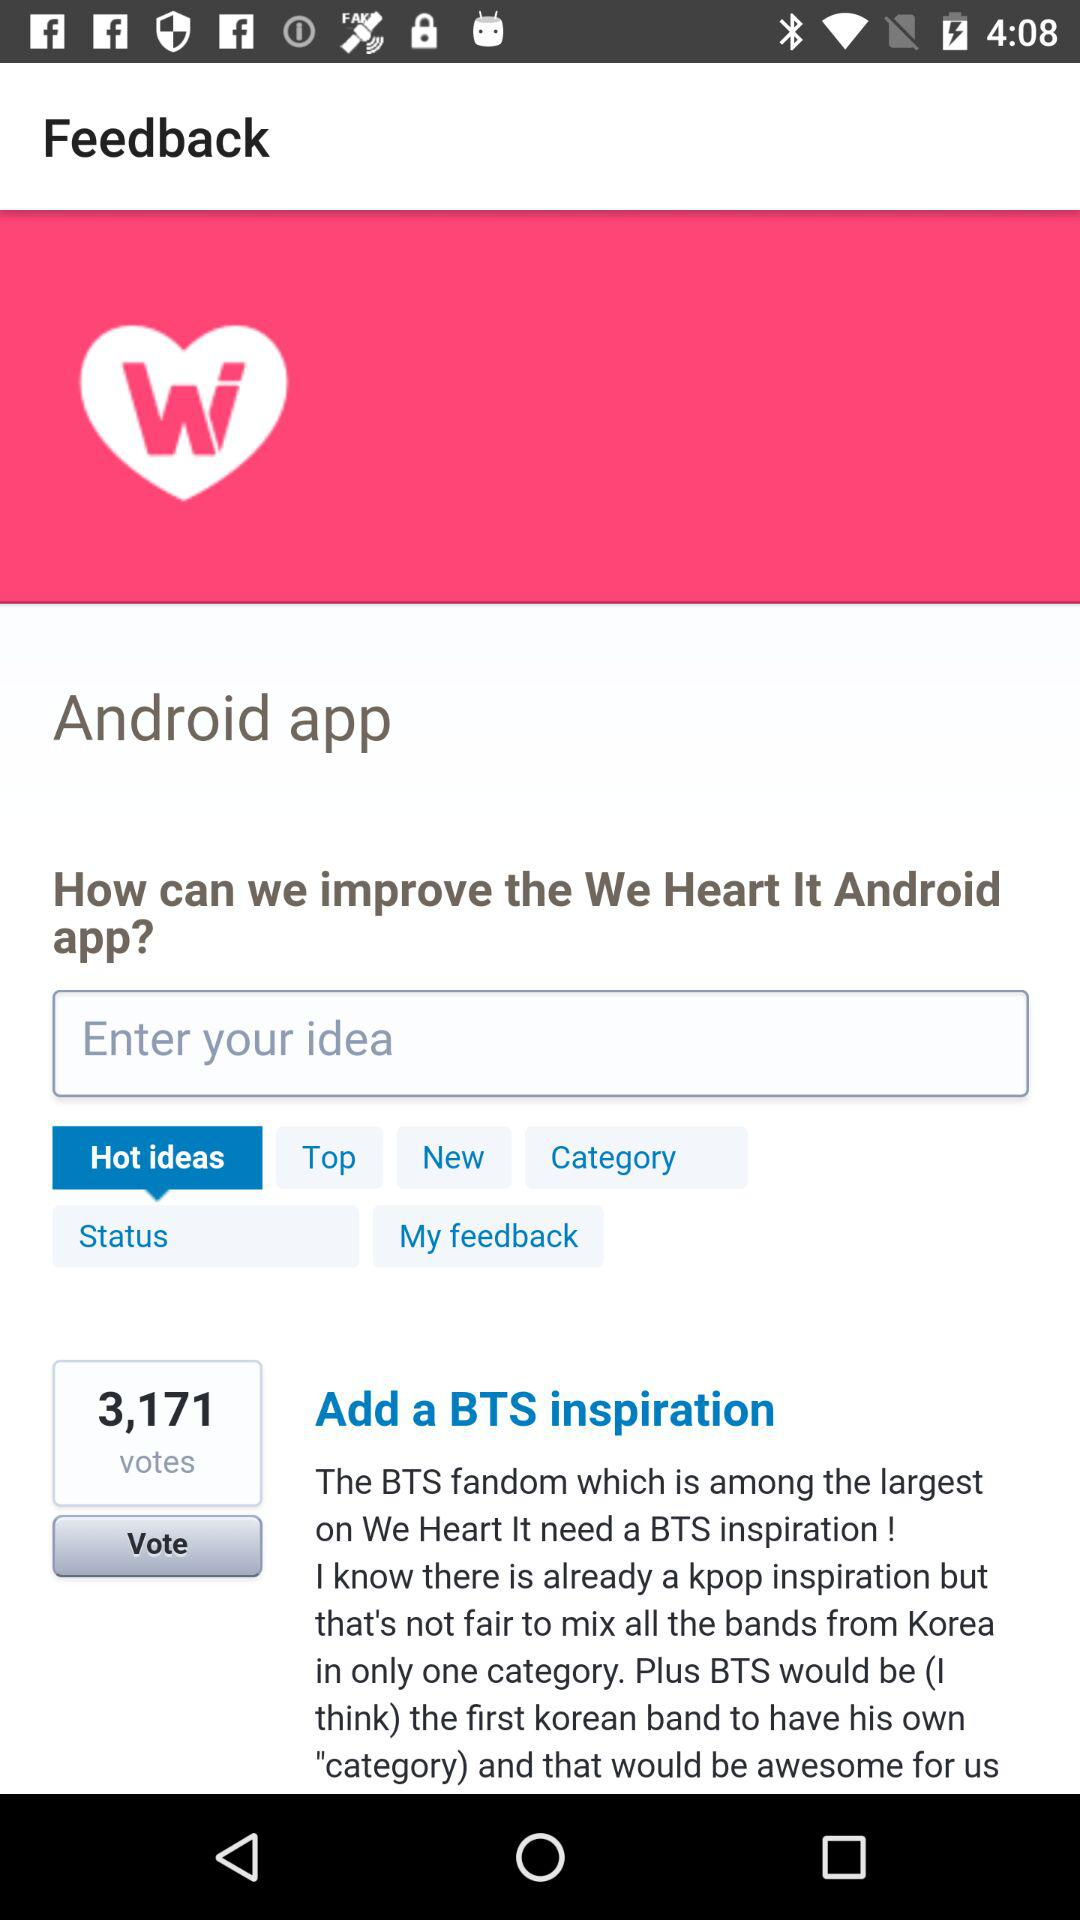What is the entered idea?
When the provided information is insufficient, respond with <no answer>. <no answer> 